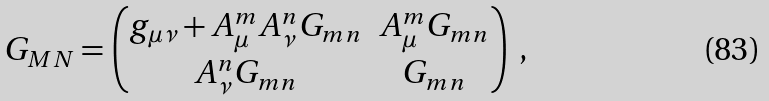<formula> <loc_0><loc_0><loc_500><loc_500>G _ { M N } = \begin{pmatrix} g _ { \mu \nu } + A _ { \mu } ^ { m } A _ { \nu } ^ { n } G _ { m n } & A _ { \mu } ^ { m } G _ { m n } \\ A _ { \nu } ^ { n } G _ { m n } & G _ { m n } \end{pmatrix} \ ,</formula> 